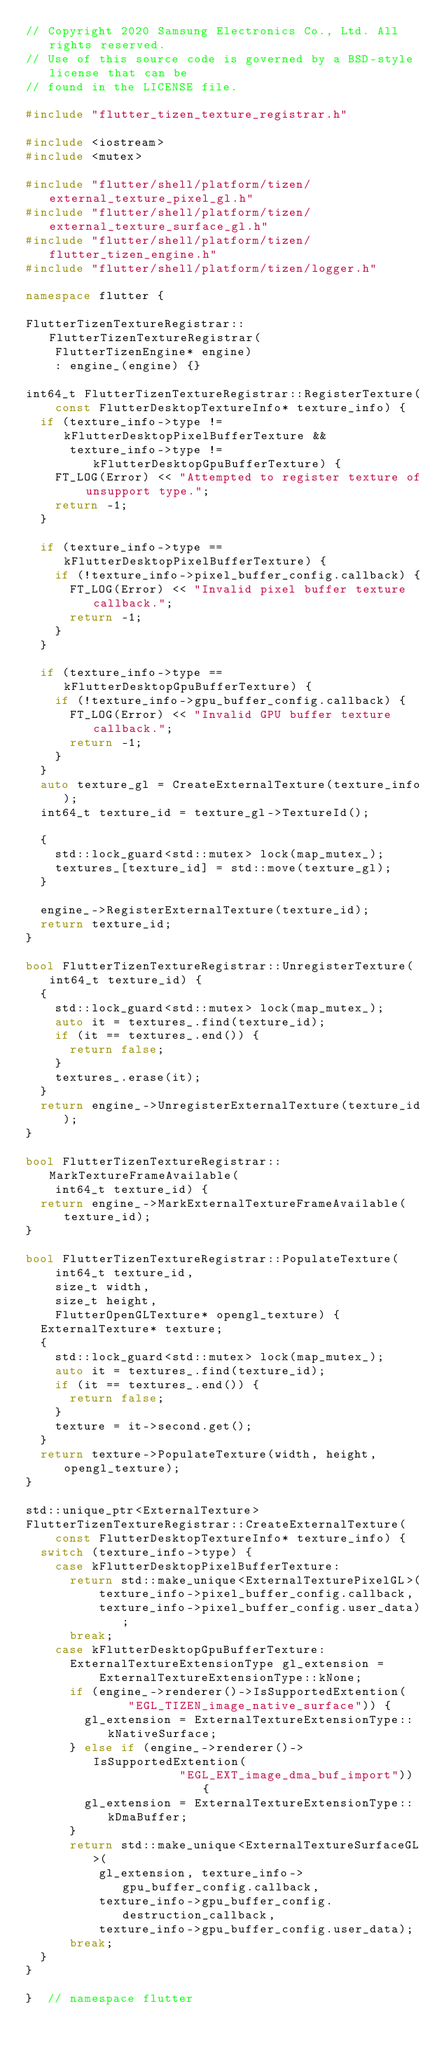Convert code to text. <code><loc_0><loc_0><loc_500><loc_500><_C++_>// Copyright 2020 Samsung Electronics Co., Ltd. All rights reserved.
// Use of this source code is governed by a BSD-style license that can be
// found in the LICENSE file.

#include "flutter_tizen_texture_registrar.h"

#include <iostream>
#include <mutex>

#include "flutter/shell/platform/tizen/external_texture_pixel_gl.h"
#include "flutter/shell/platform/tizen/external_texture_surface_gl.h"
#include "flutter/shell/platform/tizen/flutter_tizen_engine.h"
#include "flutter/shell/platform/tizen/logger.h"

namespace flutter {

FlutterTizenTextureRegistrar::FlutterTizenTextureRegistrar(
    FlutterTizenEngine* engine)
    : engine_(engine) {}

int64_t FlutterTizenTextureRegistrar::RegisterTexture(
    const FlutterDesktopTextureInfo* texture_info) {
  if (texture_info->type != kFlutterDesktopPixelBufferTexture &&
      texture_info->type != kFlutterDesktopGpuBufferTexture) {
    FT_LOG(Error) << "Attempted to register texture of unsupport type.";
    return -1;
  }

  if (texture_info->type == kFlutterDesktopPixelBufferTexture) {
    if (!texture_info->pixel_buffer_config.callback) {
      FT_LOG(Error) << "Invalid pixel buffer texture callback.";
      return -1;
    }
  }

  if (texture_info->type == kFlutterDesktopGpuBufferTexture) {
    if (!texture_info->gpu_buffer_config.callback) {
      FT_LOG(Error) << "Invalid GPU buffer texture callback.";
      return -1;
    }
  }
  auto texture_gl = CreateExternalTexture(texture_info);
  int64_t texture_id = texture_gl->TextureId();

  {
    std::lock_guard<std::mutex> lock(map_mutex_);
    textures_[texture_id] = std::move(texture_gl);
  }

  engine_->RegisterExternalTexture(texture_id);
  return texture_id;
}

bool FlutterTizenTextureRegistrar::UnregisterTexture(int64_t texture_id) {
  {
    std::lock_guard<std::mutex> lock(map_mutex_);
    auto it = textures_.find(texture_id);
    if (it == textures_.end()) {
      return false;
    }
    textures_.erase(it);
  }
  return engine_->UnregisterExternalTexture(texture_id);
}

bool FlutterTizenTextureRegistrar::MarkTextureFrameAvailable(
    int64_t texture_id) {
  return engine_->MarkExternalTextureFrameAvailable(texture_id);
}

bool FlutterTizenTextureRegistrar::PopulateTexture(
    int64_t texture_id,
    size_t width,
    size_t height,
    FlutterOpenGLTexture* opengl_texture) {
  ExternalTexture* texture;
  {
    std::lock_guard<std::mutex> lock(map_mutex_);
    auto it = textures_.find(texture_id);
    if (it == textures_.end()) {
      return false;
    }
    texture = it->second.get();
  }
  return texture->PopulateTexture(width, height, opengl_texture);
}

std::unique_ptr<ExternalTexture>
FlutterTizenTextureRegistrar::CreateExternalTexture(
    const FlutterDesktopTextureInfo* texture_info) {
  switch (texture_info->type) {
    case kFlutterDesktopPixelBufferTexture:
      return std::make_unique<ExternalTexturePixelGL>(
          texture_info->pixel_buffer_config.callback,
          texture_info->pixel_buffer_config.user_data);
      break;
    case kFlutterDesktopGpuBufferTexture:
      ExternalTextureExtensionType gl_extension =
          ExternalTextureExtensionType::kNone;
      if (engine_->renderer()->IsSupportedExtention(
              "EGL_TIZEN_image_native_surface")) {
        gl_extension = ExternalTextureExtensionType::kNativeSurface;
      } else if (engine_->renderer()->IsSupportedExtention(
                     "EGL_EXT_image_dma_buf_import")) {
        gl_extension = ExternalTextureExtensionType::kDmaBuffer;
      }
      return std::make_unique<ExternalTextureSurfaceGL>(
          gl_extension, texture_info->gpu_buffer_config.callback,
          texture_info->gpu_buffer_config.destruction_callback,
          texture_info->gpu_buffer_config.user_data);
      break;
  }
}

}  // namespace flutter
</code> 